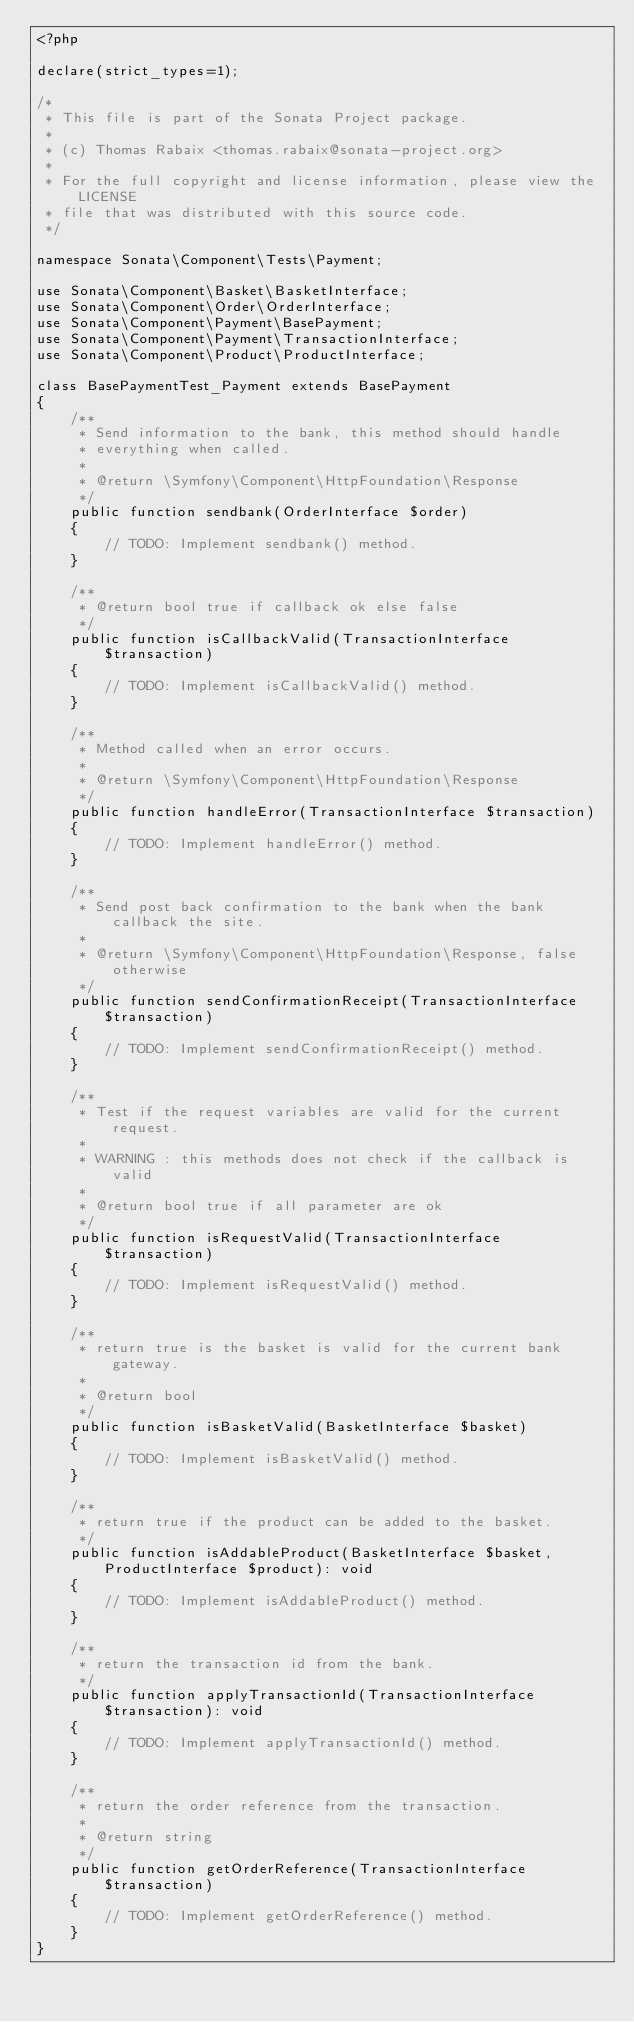Convert code to text. <code><loc_0><loc_0><loc_500><loc_500><_PHP_><?php

declare(strict_types=1);

/*
 * This file is part of the Sonata Project package.
 *
 * (c) Thomas Rabaix <thomas.rabaix@sonata-project.org>
 *
 * For the full copyright and license information, please view the LICENSE
 * file that was distributed with this source code.
 */

namespace Sonata\Component\Tests\Payment;

use Sonata\Component\Basket\BasketInterface;
use Sonata\Component\Order\OrderInterface;
use Sonata\Component\Payment\BasePayment;
use Sonata\Component\Payment\TransactionInterface;
use Sonata\Component\Product\ProductInterface;

class BasePaymentTest_Payment extends BasePayment
{
    /**
     * Send information to the bank, this method should handle
     * everything when called.
     *
     * @return \Symfony\Component\HttpFoundation\Response
     */
    public function sendbank(OrderInterface $order)
    {
        // TODO: Implement sendbank() method.
    }

    /**
     * @return bool true if callback ok else false
     */
    public function isCallbackValid(TransactionInterface $transaction)
    {
        // TODO: Implement isCallbackValid() method.
    }

    /**
     * Method called when an error occurs.
     *
     * @return \Symfony\Component\HttpFoundation\Response
     */
    public function handleError(TransactionInterface $transaction)
    {
        // TODO: Implement handleError() method.
    }

    /**
     * Send post back confirmation to the bank when the bank callback the site.
     *
     * @return \Symfony\Component\HttpFoundation\Response, false otherwise
     */
    public function sendConfirmationReceipt(TransactionInterface $transaction)
    {
        // TODO: Implement sendConfirmationReceipt() method.
    }

    /**
     * Test if the request variables are valid for the current request.
     *
     * WARNING : this methods does not check if the callback is valid
     *
     * @return bool true if all parameter are ok
     */
    public function isRequestValid(TransactionInterface $transaction)
    {
        // TODO: Implement isRequestValid() method.
    }

    /**
     * return true is the basket is valid for the current bank gateway.
     *
     * @return bool
     */
    public function isBasketValid(BasketInterface $basket)
    {
        // TODO: Implement isBasketValid() method.
    }

    /**
     * return true if the product can be added to the basket.
     */
    public function isAddableProduct(BasketInterface $basket, ProductInterface $product): void
    {
        // TODO: Implement isAddableProduct() method.
    }

    /**
     * return the transaction id from the bank.
     */
    public function applyTransactionId(TransactionInterface $transaction): void
    {
        // TODO: Implement applyTransactionId() method.
    }

    /**
     * return the order reference from the transaction.
     *
     * @return string
     */
    public function getOrderReference(TransactionInterface $transaction)
    {
        // TODO: Implement getOrderReference() method.
    }
}
</code> 